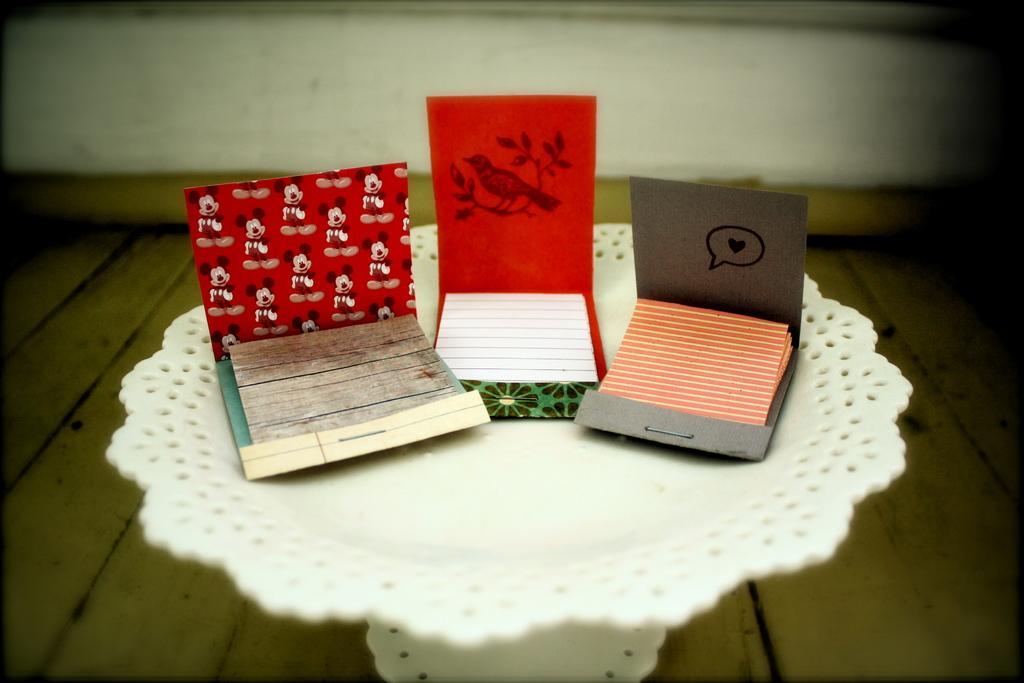Can you describe this image briefly? In this image we can a table on a wooden floor and on the table, we can see three envelopes with papers in it. 